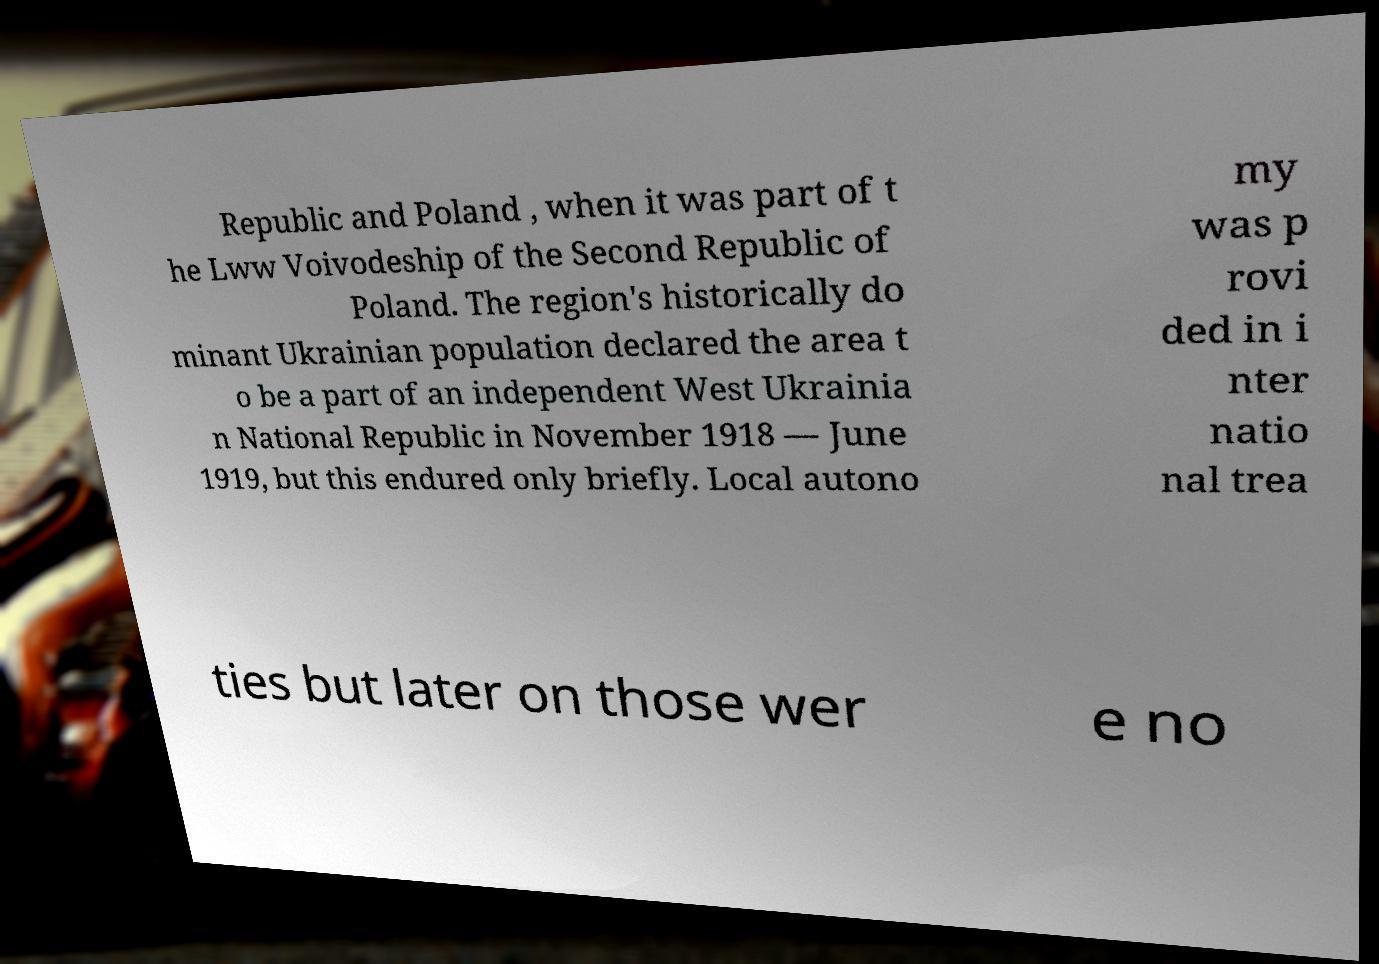There's text embedded in this image that I need extracted. Can you transcribe it verbatim? Republic and Poland , when it was part of t he Lww Voivodeship of the Second Republic of Poland. The region's historically do minant Ukrainian population declared the area t o be a part of an independent West Ukrainia n National Republic in November 1918 — June 1919, but this endured only briefly. Local autono my was p rovi ded in i nter natio nal trea ties but later on those wer e no 